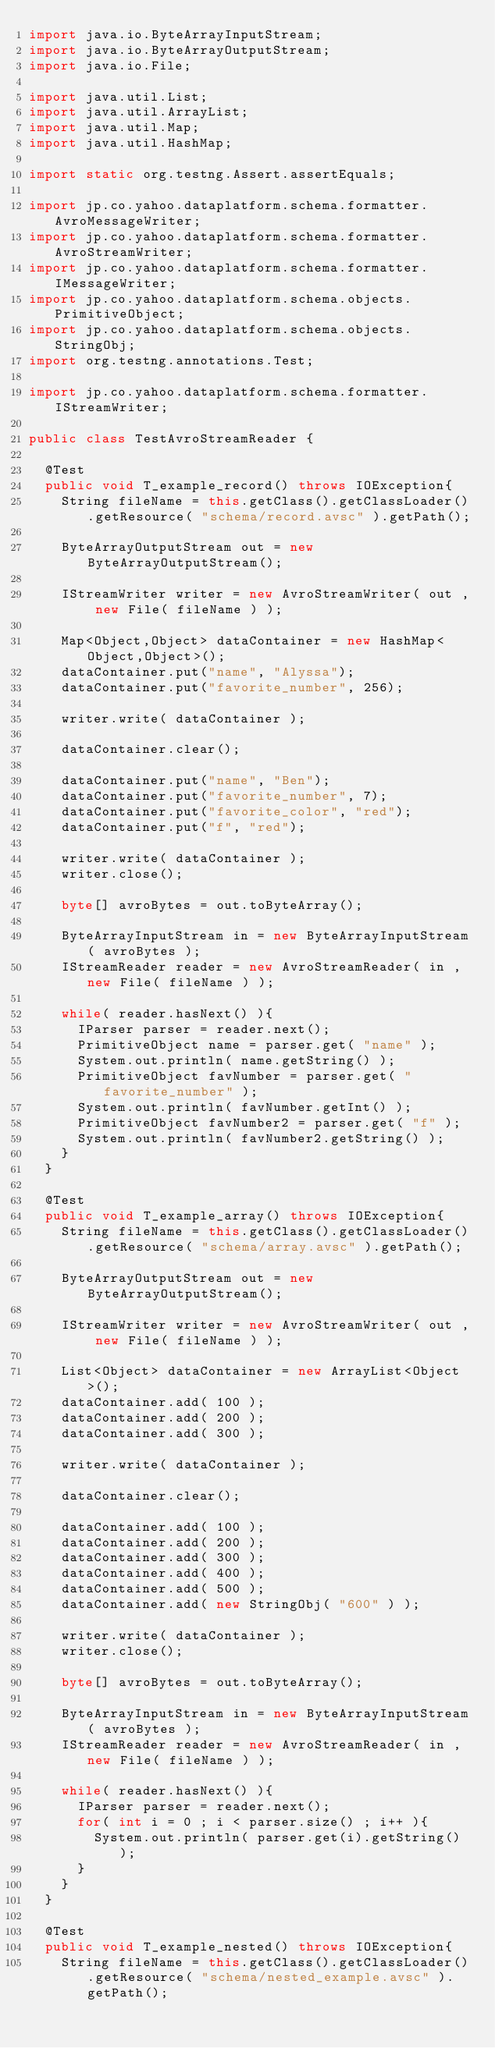<code> <loc_0><loc_0><loc_500><loc_500><_Java_>import java.io.ByteArrayInputStream;
import java.io.ByteArrayOutputStream;
import java.io.File;

import java.util.List;
import java.util.ArrayList;
import java.util.Map;
import java.util.HashMap;

import static org.testng.Assert.assertEquals;

import jp.co.yahoo.dataplatform.schema.formatter.AvroMessageWriter;
import jp.co.yahoo.dataplatform.schema.formatter.AvroStreamWriter;
import jp.co.yahoo.dataplatform.schema.formatter.IMessageWriter;
import jp.co.yahoo.dataplatform.schema.objects.PrimitiveObject;
import jp.co.yahoo.dataplatform.schema.objects.StringObj;
import org.testng.annotations.Test;

import jp.co.yahoo.dataplatform.schema.formatter.IStreamWriter;

public class TestAvroStreamReader {

  @Test
  public void T_example_record() throws IOException{
    String fileName = this.getClass().getClassLoader().getResource( "schema/record.avsc" ).getPath();

    ByteArrayOutputStream out = new ByteArrayOutputStream();

    IStreamWriter writer = new AvroStreamWriter( out , new File( fileName ) );

    Map<Object,Object> dataContainer = new HashMap<Object,Object>();
    dataContainer.put("name", "Alyssa");
    dataContainer.put("favorite_number", 256);

    writer.write( dataContainer );

    dataContainer.clear();

    dataContainer.put("name", "Ben");
    dataContainer.put("favorite_number", 7);
    dataContainer.put("favorite_color", "red");
    dataContainer.put("f", "red");

    writer.write( dataContainer );
    writer.close();

    byte[] avroBytes = out.toByteArray();

    ByteArrayInputStream in = new ByteArrayInputStream( avroBytes );
    IStreamReader reader = new AvroStreamReader( in , new File( fileName ) );

    while( reader.hasNext() ){
      IParser parser = reader.next();
      PrimitiveObject name = parser.get( "name" );
      System.out.println( name.getString() );
      PrimitiveObject favNumber = parser.get( "favorite_number" );
      System.out.println( favNumber.getInt() );
      PrimitiveObject favNumber2 = parser.get( "f" );
      System.out.println( favNumber2.getString() );
    }
  }

  @Test
  public void T_example_array() throws IOException{
    String fileName = this.getClass().getClassLoader().getResource( "schema/array.avsc" ).getPath();

    ByteArrayOutputStream out = new ByteArrayOutputStream();

    IStreamWriter writer = new AvroStreamWriter( out , new File( fileName ) );

    List<Object> dataContainer = new ArrayList<Object>();
    dataContainer.add( 100 );
    dataContainer.add( 200 );
    dataContainer.add( 300 );

    writer.write( dataContainer );

    dataContainer.clear();

    dataContainer.add( 100 );
    dataContainer.add( 200 );
    dataContainer.add( 300 );
    dataContainer.add( 400 );
    dataContainer.add( 500 );
    dataContainer.add( new StringObj( "600" ) );

    writer.write( dataContainer );
    writer.close();

    byte[] avroBytes = out.toByteArray();

    ByteArrayInputStream in = new ByteArrayInputStream( avroBytes );
    IStreamReader reader = new AvroStreamReader( in , new File( fileName ) );

    while( reader.hasNext() ){
      IParser parser = reader.next();
      for( int i = 0 ; i < parser.size() ; i++ ){
        System.out.println( parser.get(i).getString() );
      }
    }
  }

  @Test
  public void T_example_nested() throws IOException{
    String fileName = this.getClass().getClassLoader().getResource( "schema/nested_example.avsc" ).getPath();
</code> 